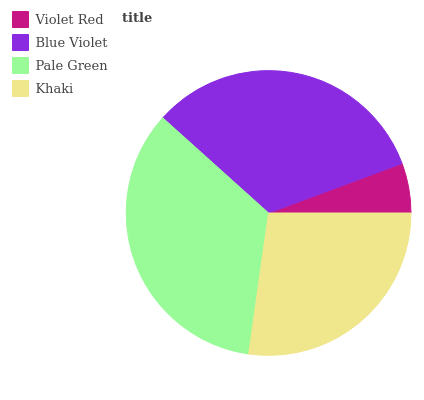Is Violet Red the minimum?
Answer yes or no. Yes. Is Pale Green the maximum?
Answer yes or no. Yes. Is Blue Violet the minimum?
Answer yes or no. No. Is Blue Violet the maximum?
Answer yes or no. No. Is Blue Violet greater than Violet Red?
Answer yes or no. Yes. Is Violet Red less than Blue Violet?
Answer yes or no. Yes. Is Violet Red greater than Blue Violet?
Answer yes or no. No. Is Blue Violet less than Violet Red?
Answer yes or no. No. Is Blue Violet the high median?
Answer yes or no. Yes. Is Khaki the low median?
Answer yes or no. Yes. Is Pale Green the high median?
Answer yes or no. No. Is Pale Green the low median?
Answer yes or no. No. 